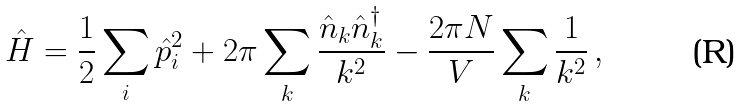<formula> <loc_0><loc_0><loc_500><loc_500>\hat { H } = \frac { 1 } { 2 } \sum _ { i } \hat { p } _ { i } ^ { 2 } + 2 \pi \sum _ { k } \frac { \hat { n } _ { k } \hat { n } ^ { \dagger } _ { k } } { k ^ { 2 } } - \frac { 2 \pi N } { V } \sum _ { k } \frac { 1 } { k ^ { 2 } } \, ,</formula> 